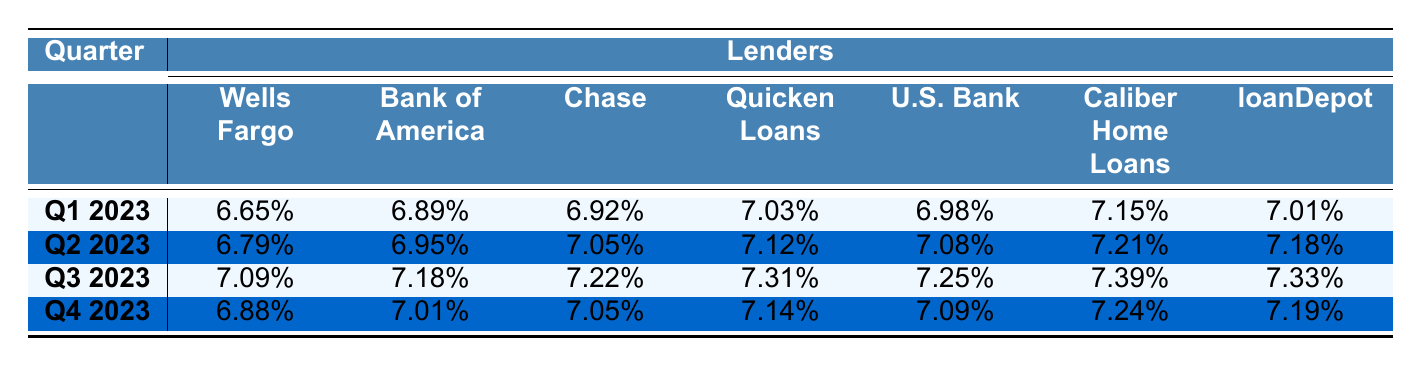What was the interest rate of Wells Fargo in Q2 2023? The table lists Wells Fargo's interest rate for Q2 2023 as 6.79%.
Answer: 6.79% Which lender had the highest interest rate in Q3 2023? By comparing the interest rates in Q3 2023, Chase had the highest rate at 7.22%.
Answer: Chase What is the average interest rate for Quicken Loans across all quarters? The rates for Quicken Loans are 7.03%, 7.12%, 7.31%, and 7.14%. Summing these gives 28.60%. Dividing by 4 (the number of quarters) gives an average of 7.15%.
Answer: 7.15% Did the interest rate for U.S. Bank increase from Q1 to Q4 2023? U.S. Bank's rates are 6.98% in Q1 and 7.09% in Q4. Since 7.09% is greater than 6.98%, it did increase.
Answer: Yes What is the difference in interest rates between the lowest and highest rates for Caliber Home Loans in 2023? Caliber Home Loans' rates for the quarters are 7.15%, 7.21%, 7.39%, and 7.24%. The lowest is 7.15% and the highest is 7.39%. The difference is 7.39% - 7.15% = 0.24%.
Answer: 0.24% What was the median interest rate for Bank of America in 2023? The rates for Bank of America are 6.89%, 6.95%, 7.05%, 7.01%, 7.08%, 7.21%, and 7.18%. Arranging them in order gives 6.89%, 6.95%, 7.01%, 7.05%, 7.08%, 7.18%, 7.21%. The middle value is 7.05%.
Answer: 7.05% Which lender has the most consistent interest rates, based on the given data? To check which lender has the smallest variation in rates, look at standard deviations or ranges. Quicken Loans has rates of 7.03%, 7.12%, 7.31%, and 7.14% which vary least compared to others.
Answer: Quicken Loans What was the interest rate trend for Chase from Q1 to Q4 2023? Chase's rates are 6.92%, 7.05%, 7.22%, and 7.05%. The trend shows an increase from Q1 to Q3 followed by a decrease in Q4.
Answer: Increase then decrease Overall, did the mortgage interest rates for lenders generally increase or decrease throughout the year? A review of the interest rates shows that many lenders experienced increases toward Q3 and slight decreases in Q4. Thus, it indicates volatility.
Answer: Volatile with slight decreases in Q4 